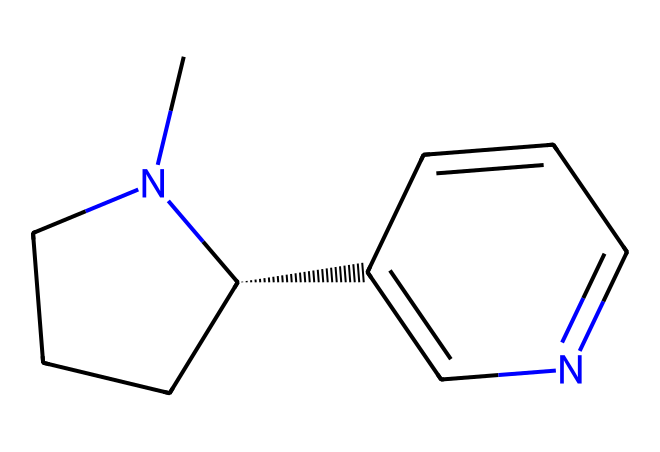What is the basic name of this chemical? The SMILES representation corresponds to nicotine, which is a well-known alkaloid and is classified as a toxic substance found in tobacco.
Answer: nicotine How many carbon atoms are present in this structure? By analyzing the SMILES, we can count the number of carbon atoms in the chemical. There are 10 carbon atoms indicated in the structure.
Answer: 10 What type of chemical bond connects the carbons? The carbons are connected primarily by single (sigma) bonds, but there are also double bonds between some of the carbon atoms and the nitrogen.
Answer: single and double bonds Which functional group is present in nicotine? The presence of the nitrogen atom in the chemical structure indicates that nicotine contains an amine functional group, which is typical for alkaloids.
Answer: amine What is the number of nitrogen atoms in this compound? In the provided SMILES representation, there are two nitrogen atoms visible, which can be counted directly from the structure.
Answer: 2 What type of molecular structure does nicotine exhibit? The chemical structure indicates that nicotine has a bicyclic structure due to the arrangement of its rings that include both fused and non-fused rings.
Answer: bicyclic How does the presence of nitrogen affect the toxicity of nicotine? The nitrogen atoms contribute to the basic nature of nicotine, which allows it to function as a neurotoxin because it can interact with acetylcholine receptors in the nervous system.
Answer: neurotoxin 